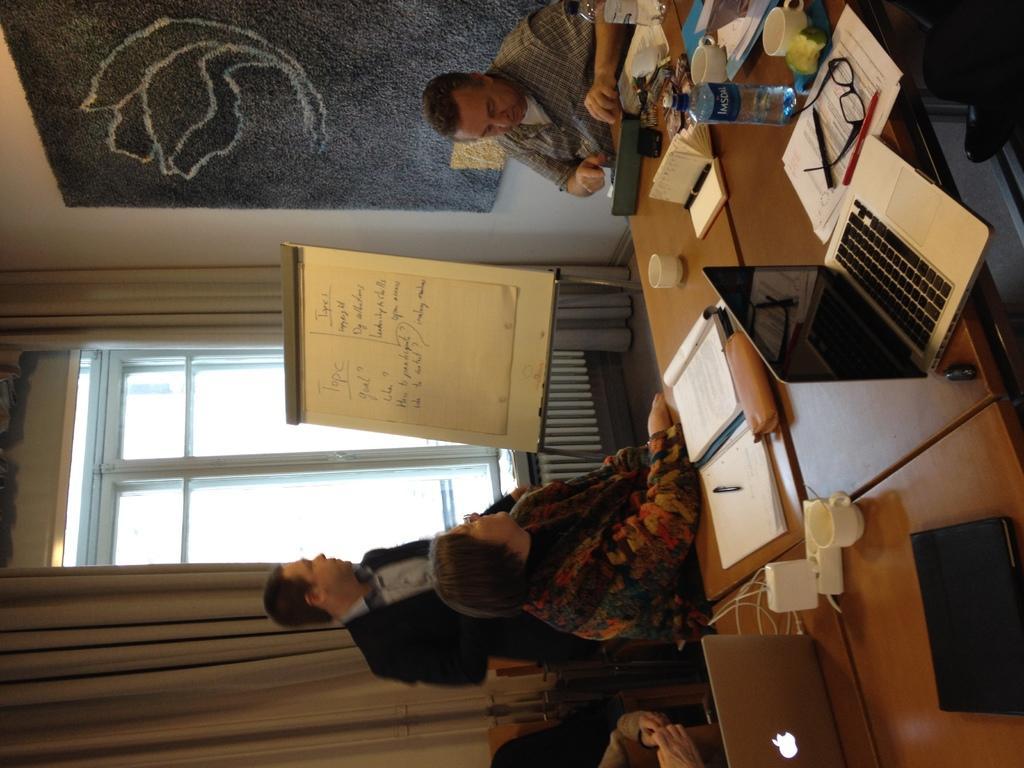Can you describe this image briefly? In this image, we can see two persons wearing clothes and sitting in front of the table. This table contains bottle, laptops and books. There is a board in the middle of the image. There is a person standing in front of the window contains curtains. 